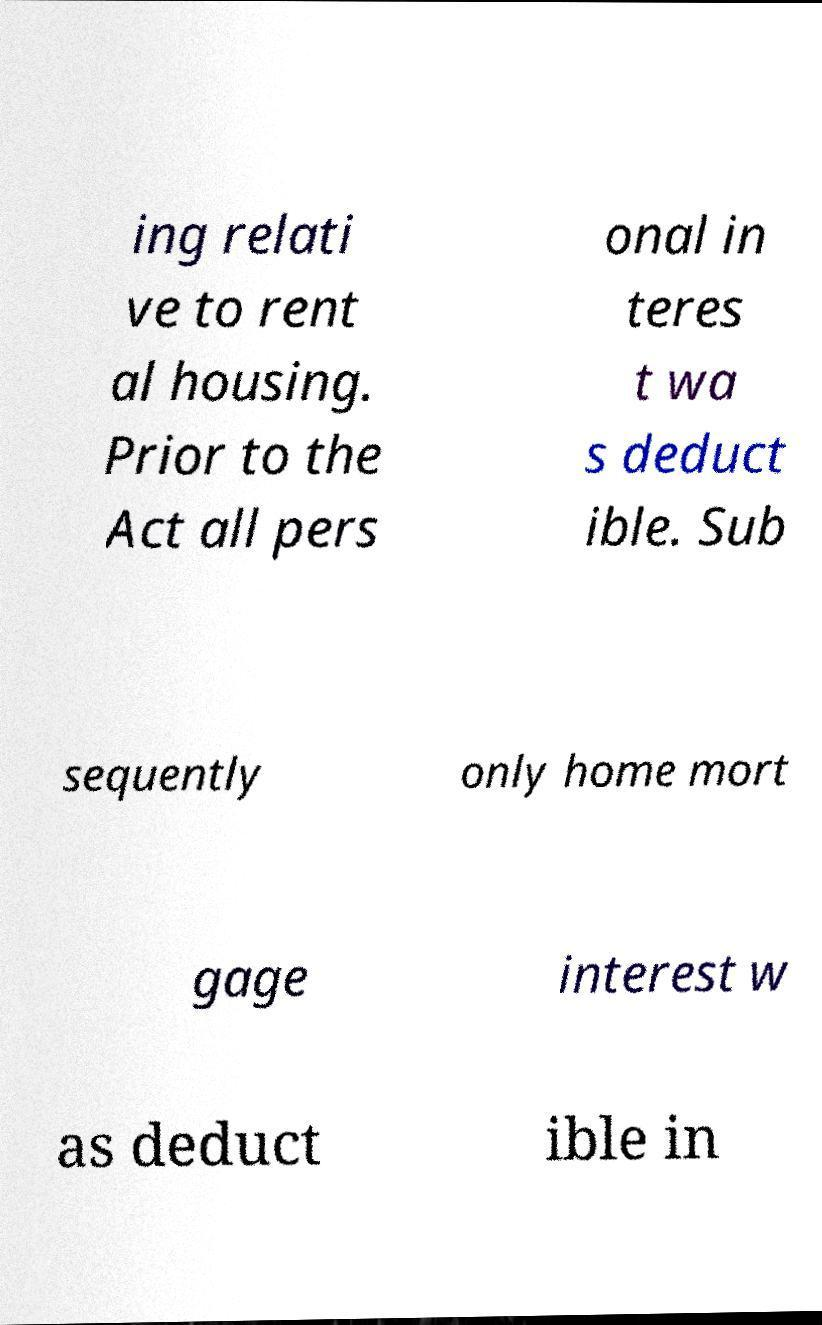For documentation purposes, I need the text within this image transcribed. Could you provide that? ing relati ve to rent al housing. Prior to the Act all pers onal in teres t wa s deduct ible. Sub sequently only home mort gage interest w as deduct ible in 